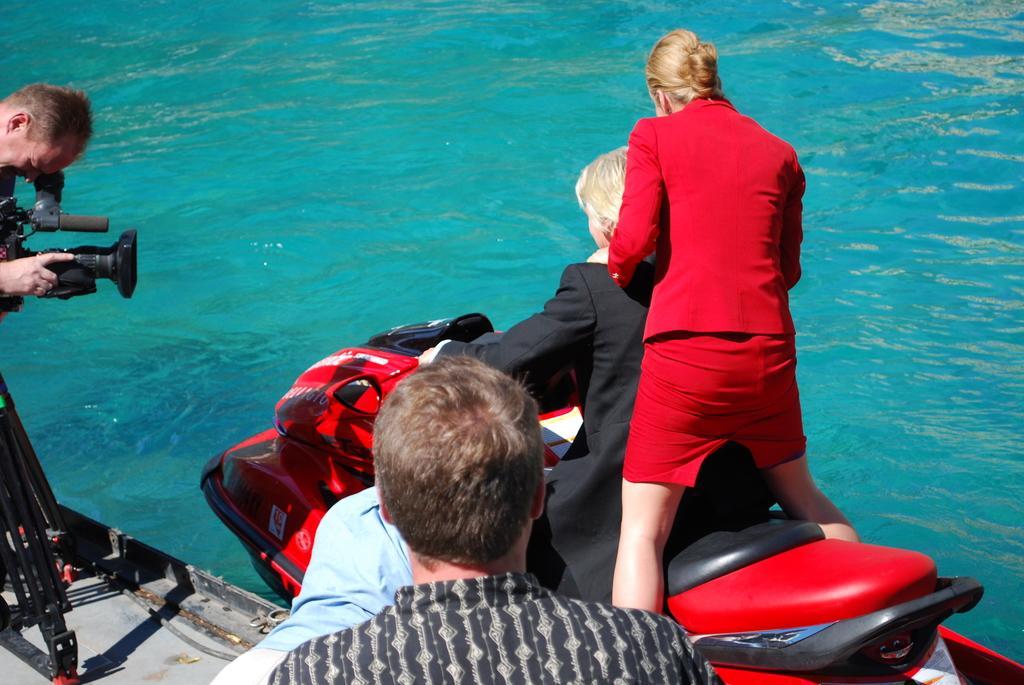How would you summarize this image in a sentence or two? There are people in the foreground area of the image, there is a person holding a camera, there are two people on the boat bike on the water in the background. 